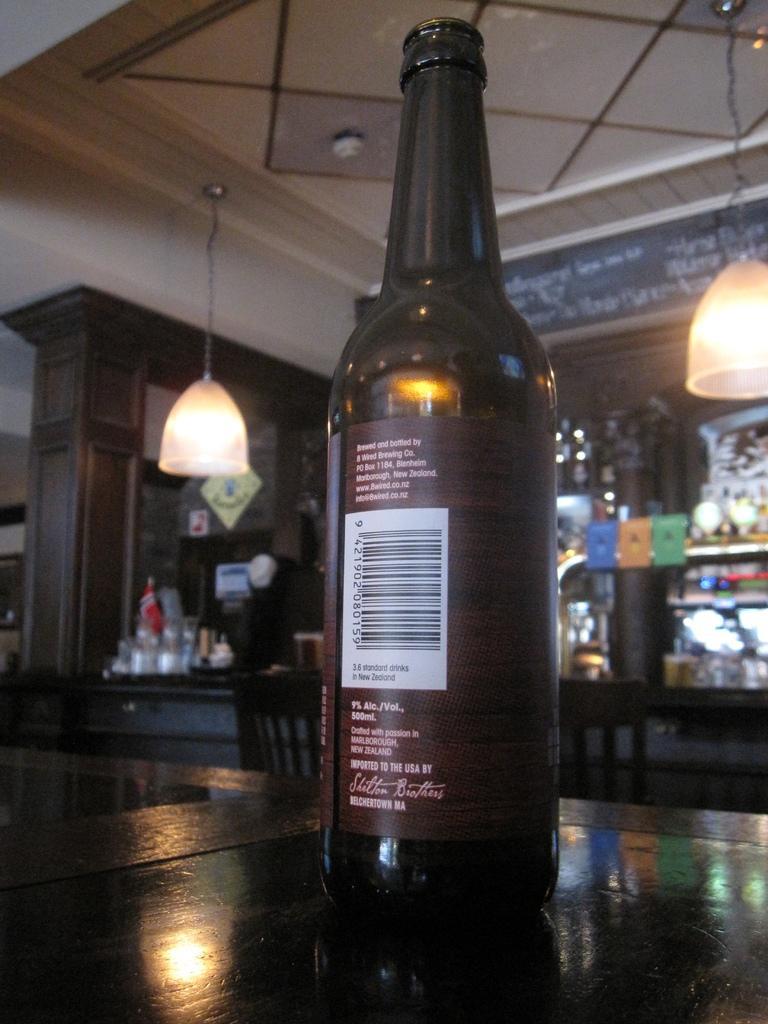Please provide a concise description of this image. In the image there is a wine bottle on the table and over the background there are lights hanging and it seems to be a bar area. 